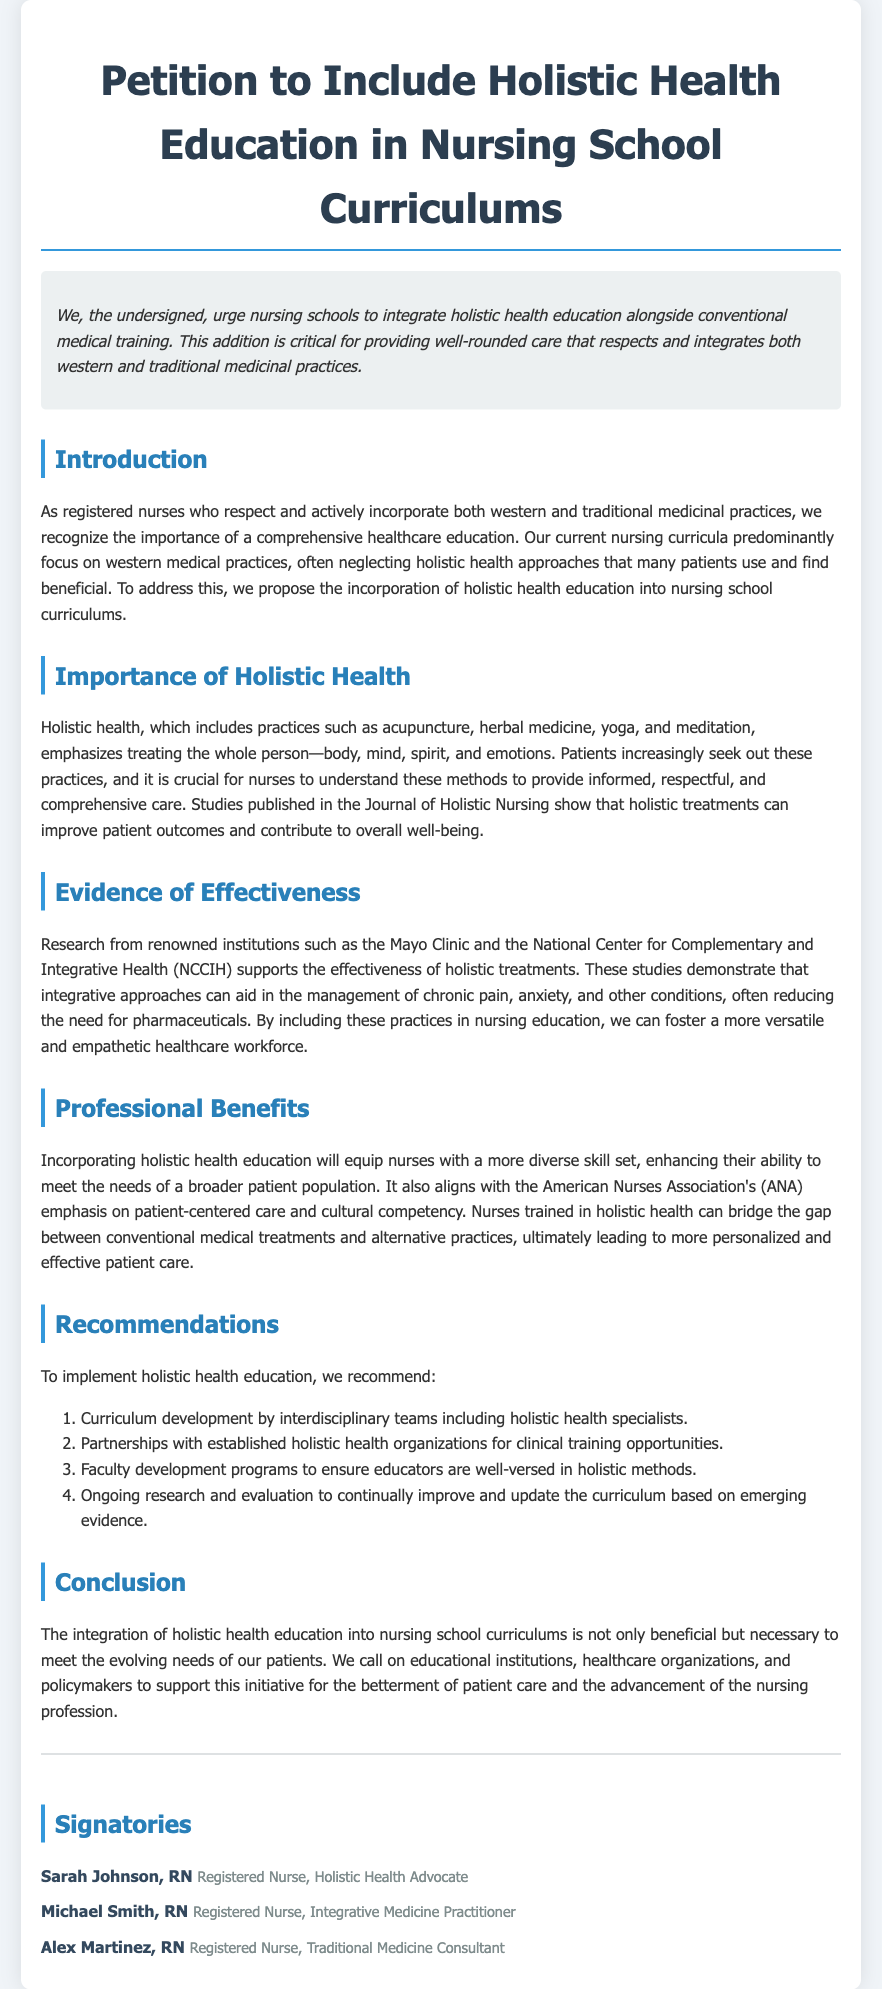What is the title of the petition? The title of the petition is found at the top of the document.
Answer: Petition to Include Holistic Health Education in Nursing School Curriculums Who is the intended audience for the petition? The petition is directed towards educational institutions, healthcare organizations, and policymakers.
Answer: Educational institutions, healthcare organizations, and policymakers What type of health practices are emphasized in the document? The document emphasizes a range of health practices that include holistic approaches alongside conventional ones.
Answer: Holistic health practices Which organization’s emphasis is mentioned in relation to patient-centered care? The American Nurses Association is mentioned in the document regarding patient-centered care.
Answer: American Nurses Association What are the four recommendations provided in the petition? The recommendation section outlines four specific actions without needing detailed descriptions.
Answer: Curriculum development, partnerships, faculty development, ongoing research What year is referenced in the studies mentioned? The document cites studies from specific institutions, including the Mayo Clinic, but does not provide a year.
Answer: Not specified How many signatories are listed in the document? The number of signatories can be counted based on the signatory section of the document.
Answer: Three What is included in the summary section of the document? The summary section introduces the urgency and intention behind the petition in a concise manner.
Answer: Urge nursing schools to integrate holistic health education 